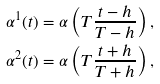Convert formula to latex. <formula><loc_0><loc_0><loc_500><loc_500>\alpha ^ { 1 } ( t ) & = \alpha \left ( T \frac { t - h } { T - h } \right ) , \\ \alpha ^ { 2 } ( t ) & = \alpha \left ( T \frac { t + h } { T + h } \right ) , \\</formula> 